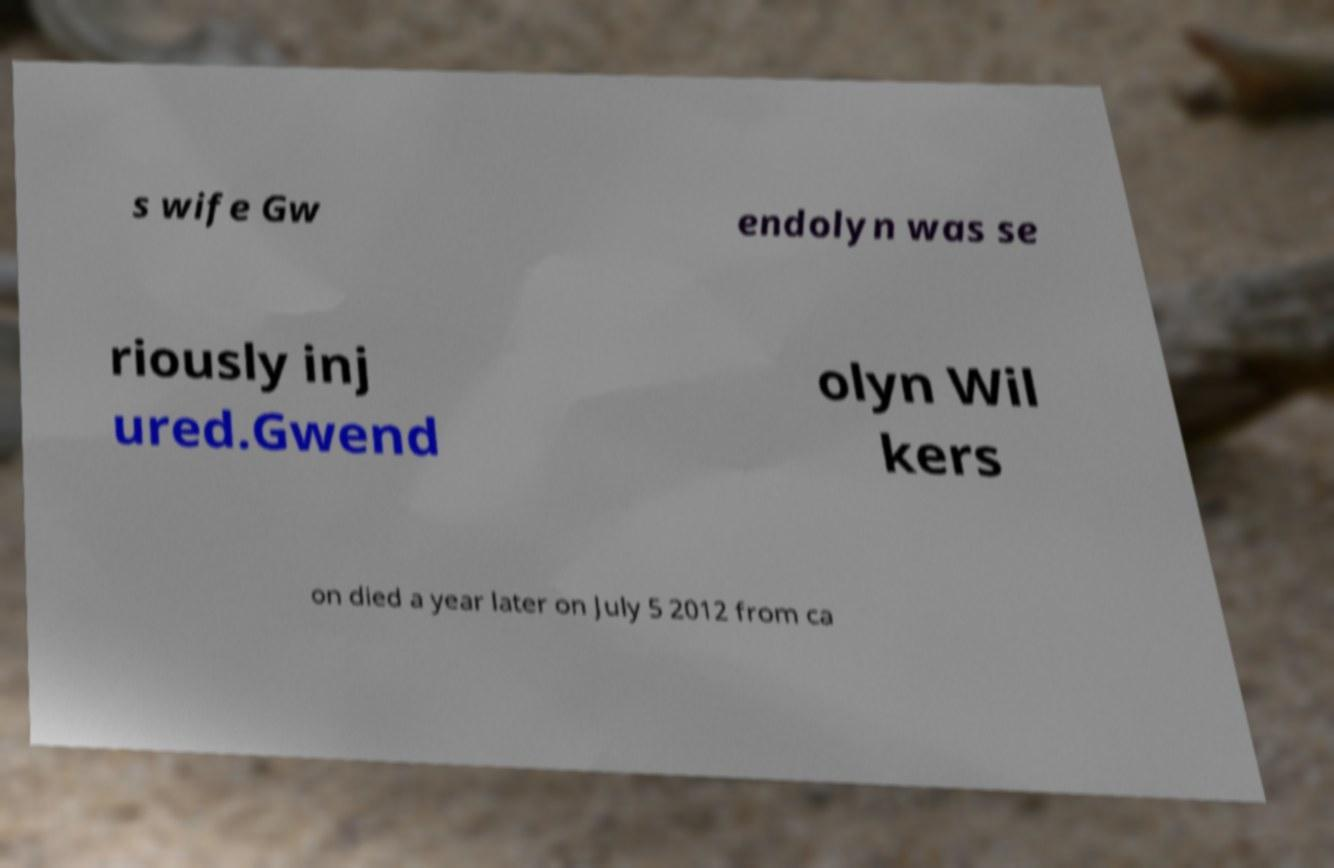What messages or text are displayed in this image? I need them in a readable, typed format. s wife Gw endolyn was se riously inj ured.Gwend olyn Wil kers on died a year later on July 5 2012 from ca 